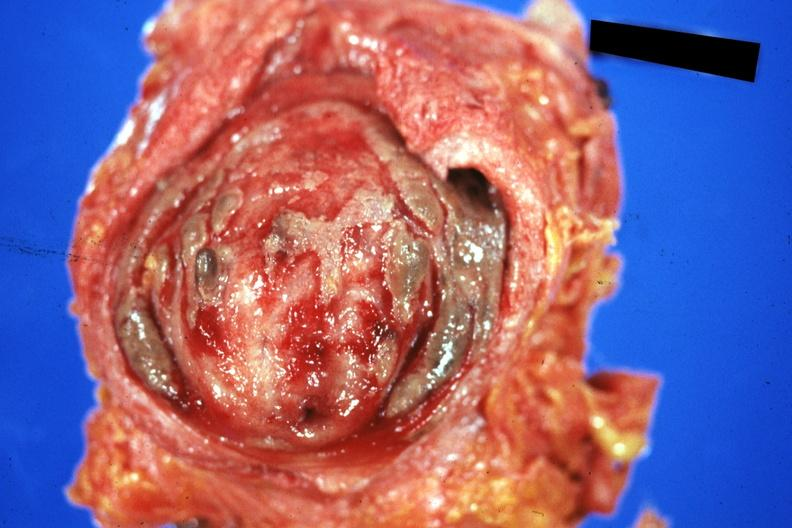s bladder present?
Answer the question using a single word or phrase. Yes 